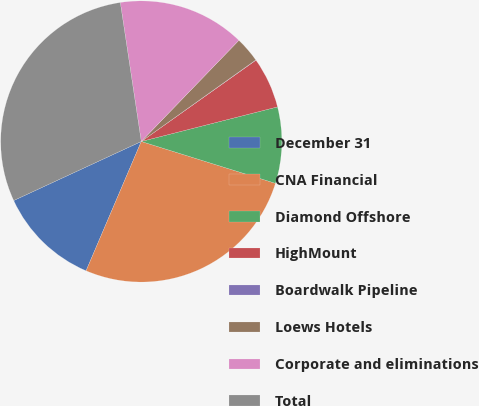<chart> <loc_0><loc_0><loc_500><loc_500><pie_chart><fcel>December 31<fcel>CNA Financial<fcel>Diamond Offshore<fcel>HighMount<fcel>Boardwalk Pipeline<fcel>Loews Hotels<fcel>Corporate and eliminations<fcel>Total<nl><fcel>11.68%<fcel>26.61%<fcel>8.77%<fcel>5.86%<fcel>0.03%<fcel>2.94%<fcel>14.6%<fcel>29.52%<nl></chart> 